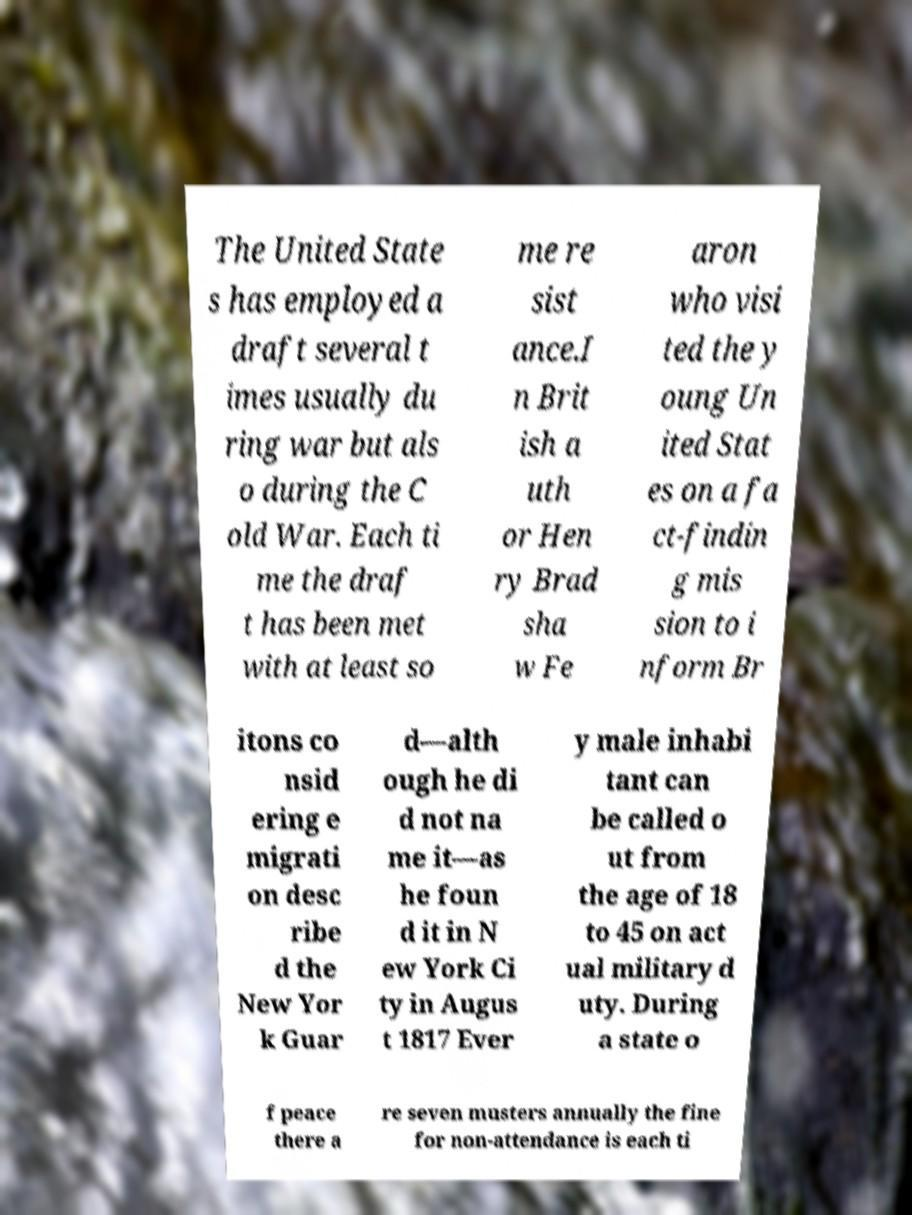Can you accurately transcribe the text from the provided image for me? The United State s has employed a draft several t imes usually du ring war but als o during the C old War. Each ti me the draf t has been met with at least so me re sist ance.I n Brit ish a uth or Hen ry Brad sha w Fe aron who visi ted the y oung Un ited Stat es on a fa ct-findin g mis sion to i nform Br itons co nsid ering e migrati on desc ribe d the New Yor k Guar d—alth ough he di d not na me it—as he foun d it in N ew York Ci ty in Augus t 1817 Ever y male inhabi tant can be called o ut from the age of 18 to 45 on act ual military d uty. During a state o f peace there a re seven musters annually the fine for non-attendance is each ti 